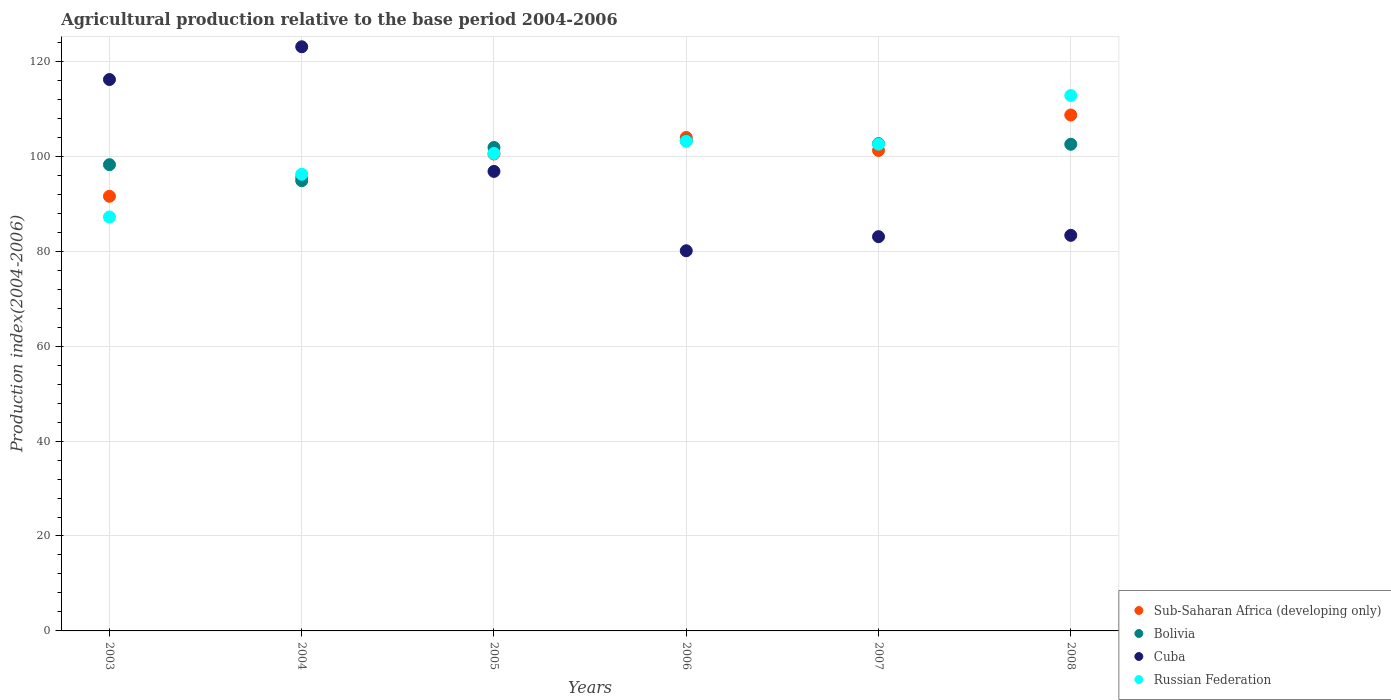How many different coloured dotlines are there?
Offer a terse response. 4. Is the number of dotlines equal to the number of legend labels?
Give a very brief answer. Yes. What is the agricultural production index in Cuba in 2005?
Make the answer very short. 96.82. Across all years, what is the maximum agricultural production index in Sub-Saharan Africa (developing only)?
Offer a terse response. 108.7. Across all years, what is the minimum agricultural production index in Bolivia?
Give a very brief answer. 94.86. In which year was the agricultural production index in Sub-Saharan Africa (developing only) maximum?
Your answer should be very brief. 2008. What is the total agricultural production index in Sub-Saharan Africa (developing only) in the graph?
Offer a very short reply. 601.52. What is the difference between the agricultural production index in Russian Federation in 2003 and that in 2008?
Offer a very short reply. -25.59. What is the difference between the agricultural production index in Bolivia in 2004 and the agricultural production index in Sub-Saharan Africa (developing only) in 2008?
Your response must be concise. -13.84. What is the average agricultural production index in Sub-Saharan Africa (developing only) per year?
Ensure brevity in your answer.  100.25. In the year 2006, what is the difference between the agricultural production index in Sub-Saharan Africa (developing only) and agricultural production index in Bolivia?
Provide a succinct answer. 0.69. In how many years, is the agricultural production index in Russian Federation greater than 80?
Provide a short and direct response. 6. What is the ratio of the agricultural production index in Cuba in 2004 to that in 2007?
Your answer should be very brief. 1.48. Is the difference between the agricultural production index in Sub-Saharan Africa (developing only) in 2003 and 2004 greater than the difference between the agricultural production index in Bolivia in 2003 and 2004?
Your answer should be very brief. No. What is the difference between the highest and the second highest agricultural production index in Cuba?
Keep it short and to the point. 6.9. What is the difference between the highest and the lowest agricultural production index in Cuba?
Your response must be concise. 42.98. Does the agricultural production index in Sub-Saharan Africa (developing only) monotonically increase over the years?
Ensure brevity in your answer.  No. Is the agricultural production index in Sub-Saharan Africa (developing only) strictly greater than the agricultural production index in Cuba over the years?
Give a very brief answer. No. Is the agricultural production index in Bolivia strictly less than the agricultural production index in Russian Federation over the years?
Offer a terse response. No. Does the graph contain any zero values?
Make the answer very short. No. Does the graph contain grids?
Make the answer very short. Yes. How are the legend labels stacked?
Make the answer very short. Vertical. What is the title of the graph?
Your answer should be compact. Agricultural production relative to the base period 2004-2006. Does "Middle East & North Africa (developing only)" appear as one of the legend labels in the graph?
Ensure brevity in your answer.  No. What is the label or title of the X-axis?
Offer a very short reply. Years. What is the label or title of the Y-axis?
Your answer should be compact. Production index(2004-2006). What is the Production index(2004-2006) of Sub-Saharan Africa (developing only) in 2003?
Your answer should be very brief. 91.58. What is the Production index(2004-2006) of Bolivia in 2003?
Make the answer very short. 98.24. What is the Production index(2004-2006) in Cuba in 2003?
Offer a terse response. 116.18. What is the Production index(2004-2006) of Russian Federation in 2003?
Your answer should be compact. 87.22. What is the Production index(2004-2006) of Sub-Saharan Africa (developing only) in 2004?
Provide a succinct answer. 95.55. What is the Production index(2004-2006) of Bolivia in 2004?
Your response must be concise. 94.86. What is the Production index(2004-2006) of Cuba in 2004?
Provide a succinct answer. 123.08. What is the Production index(2004-2006) of Russian Federation in 2004?
Keep it short and to the point. 96.22. What is the Production index(2004-2006) in Sub-Saharan Africa (developing only) in 2005?
Offer a very short reply. 100.48. What is the Production index(2004-2006) in Bolivia in 2005?
Keep it short and to the point. 101.86. What is the Production index(2004-2006) of Cuba in 2005?
Give a very brief answer. 96.82. What is the Production index(2004-2006) in Russian Federation in 2005?
Your answer should be very brief. 100.61. What is the Production index(2004-2006) in Sub-Saharan Africa (developing only) in 2006?
Provide a short and direct response. 103.97. What is the Production index(2004-2006) in Bolivia in 2006?
Give a very brief answer. 103.28. What is the Production index(2004-2006) in Cuba in 2006?
Offer a very short reply. 80.1. What is the Production index(2004-2006) of Russian Federation in 2006?
Provide a short and direct response. 103.17. What is the Production index(2004-2006) of Sub-Saharan Africa (developing only) in 2007?
Your response must be concise. 101.24. What is the Production index(2004-2006) of Bolivia in 2007?
Offer a very short reply. 102.68. What is the Production index(2004-2006) of Cuba in 2007?
Give a very brief answer. 83.07. What is the Production index(2004-2006) in Russian Federation in 2007?
Your answer should be compact. 102.56. What is the Production index(2004-2006) of Sub-Saharan Africa (developing only) in 2008?
Offer a very short reply. 108.7. What is the Production index(2004-2006) of Bolivia in 2008?
Offer a terse response. 102.54. What is the Production index(2004-2006) in Cuba in 2008?
Keep it short and to the point. 83.35. What is the Production index(2004-2006) of Russian Federation in 2008?
Keep it short and to the point. 112.81. Across all years, what is the maximum Production index(2004-2006) of Sub-Saharan Africa (developing only)?
Make the answer very short. 108.7. Across all years, what is the maximum Production index(2004-2006) of Bolivia?
Your answer should be very brief. 103.28. Across all years, what is the maximum Production index(2004-2006) of Cuba?
Your response must be concise. 123.08. Across all years, what is the maximum Production index(2004-2006) of Russian Federation?
Offer a very short reply. 112.81. Across all years, what is the minimum Production index(2004-2006) in Sub-Saharan Africa (developing only)?
Provide a short and direct response. 91.58. Across all years, what is the minimum Production index(2004-2006) of Bolivia?
Your response must be concise. 94.86. Across all years, what is the minimum Production index(2004-2006) in Cuba?
Offer a terse response. 80.1. Across all years, what is the minimum Production index(2004-2006) in Russian Federation?
Your answer should be very brief. 87.22. What is the total Production index(2004-2006) of Sub-Saharan Africa (developing only) in the graph?
Your answer should be very brief. 601.52. What is the total Production index(2004-2006) in Bolivia in the graph?
Make the answer very short. 603.46. What is the total Production index(2004-2006) in Cuba in the graph?
Your response must be concise. 582.6. What is the total Production index(2004-2006) in Russian Federation in the graph?
Provide a succinct answer. 602.59. What is the difference between the Production index(2004-2006) in Sub-Saharan Africa (developing only) in 2003 and that in 2004?
Offer a terse response. -3.97. What is the difference between the Production index(2004-2006) in Bolivia in 2003 and that in 2004?
Offer a terse response. 3.38. What is the difference between the Production index(2004-2006) of Cuba in 2003 and that in 2004?
Offer a terse response. -6.9. What is the difference between the Production index(2004-2006) of Sub-Saharan Africa (developing only) in 2003 and that in 2005?
Your answer should be very brief. -8.9. What is the difference between the Production index(2004-2006) in Bolivia in 2003 and that in 2005?
Give a very brief answer. -3.62. What is the difference between the Production index(2004-2006) of Cuba in 2003 and that in 2005?
Your answer should be compact. 19.36. What is the difference between the Production index(2004-2006) in Russian Federation in 2003 and that in 2005?
Provide a succinct answer. -13.39. What is the difference between the Production index(2004-2006) of Sub-Saharan Africa (developing only) in 2003 and that in 2006?
Offer a very short reply. -12.4. What is the difference between the Production index(2004-2006) in Bolivia in 2003 and that in 2006?
Offer a very short reply. -5.04. What is the difference between the Production index(2004-2006) in Cuba in 2003 and that in 2006?
Your answer should be compact. 36.08. What is the difference between the Production index(2004-2006) of Russian Federation in 2003 and that in 2006?
Make the answer very short. -15.95. What is the difference between the Production index(2004-2006) of Sub-Saharan Africa (developing only) in 2003 and that in 2007?
Give a very brief answer. -9.67. What is the difference between the Production index(2004-2006) of Bolivia in 2003 and that in 2007?
Ensure brevity in your answer.  -4.44. What is the difference between the Production index(2004-2006) of Cuba in 2003 and that in 2007?
Ensure brevity in your answer.  33.11. What is the difference between the Production index(2004-2006) of Russian Federation in 2003 and that in 2007?
Give a very brief answer. -15.34. What is the difference between the Production index(2004-2006) of Sub-Saharan Africa (developing only) in 2003 and that in 2008?
Offer a very short reply. -17.13. What is the difference between the Production index(2004-2006) of Cuba in 2003 and that in 2008?
Provide a succinct answer. 32.83. What is the difference between the Production index(2004-2006) in Russian Federation in 2003 and that in 2008?
Your answer should be compact. -25.59. What is the difference between the Production index(2004-2006) in Sub-Saharan Africa (developing only) in 2004 and that in 2005?
Make the answer very short. -4.93. What is the difference between the Production index(2004-2006) of Cuba in 2004 and that in 2005?
Give a very brief answer. 26.26. What is the difference between the Production index(2004-2006) in Russian Federation in 2004 and that in 2005?
Your response must be concise. -4.39. What is the difference between the Production index(2004-2006) in Sub-Saharan Africa (developing only) in 2004 and that in 2006?
Make the answer very short. -8.43. What is the difference between the Production index(2004-2006) of Bolivia in 2004 and that in 2006?
Ensure brevity in your answer.  -8.42. What is the difference between the Production index(2004-2006) of Cuba in 2004 and that in 2006?
Provide a short and direct response. 42.98. What is the difference between the Production index(2004-2006) of Russian Federation in 2004 and that in 2006?
Ensure brevity in your answer.  -6.95. What is the difference between the Production index(2004-2006) in Sub-Saharan Africa (developing only) in 2004 and that in 2007?
Ensure brevity in your answer.  -5.69. What is the difference between the Production index(2004-2006) in Bolivia in 2004 and that in 2007?
Make the answer very short. -7.82. What is the difference between the Production index(2004-2006) of Cuba in 2004 and that in 2007?
Make the answer very short. 40.01. What is the difference between the Production index(2004-2006) in Russian Federation in 2004 and that in 2007?
Your response must be concise. -6.34. What is the difference between the Production index(2004-2006) of Sub-Saharan Africa (developing only) in 2004 and that in 2008?
Give a very brief answer. -13.15. What is the difference between the Production index(2004-2006) in Bolivia in 2004 and that in 2008?
Provide a short and direct response. -7.68. What is the difference between the Production index(2004-2006) of Cuba in 2004 and that in 2008?
Your answer should be very brief. 39.73. What is the difference between the Production index(2004-2006) in Russian Federation in 2004 and that in 2008?
Provide a short and direct response. -16.59. What is the difference between the Production index(2004-2006) of Sub-Saharan Africa (developing only) in 2005 and that in 2006?
Offer a terse response. -3.5. What is the difference between the Production index(2004-2006) in Bolivia in 2005 and that in 2006?
Offer a terse response. -1.42. What is the difference between the Production index(2004-2006) in Cuba in 2005 and that in 2006?
Your answer should be very brief. 16.72. What is the difference between the Production index(2004-2006) in Russian Federation in 2005 and that in 2006?
Offer a very short reply. -2.56. What is the difference between the Production index(2004-2006) of Sub-Saharan Africa (developing only) in 2005 and that in 2007?
Your answer should be compact. -0.76. What is the difference between the Production index(2004-2006) in Bolivia in 2005 and that in 2007?
Offer a very short reply. -0.82. What is the difference between the Production index(2004-2006) in Cuba in 2005 and that in 2007?
Give a very brief answer. 13.75. What is the difference between the Production index(2004-2006) of Russian Federation in 2005 and that in 2007?
Give a very brief answer. -1.95. What is the difference between the Production index(2004-2006) in Sub-Saharan Africa (developing only) in 2005 and that in 2008?
Keep it short and to the point. -8.22. What is the difference between the Production index(2004-2006) in Bolivia in 2005 and that in 2008?
Ensure brevity in your answer.  -0.68. What is the difference between the Production index(2004-2006) in Cuba in 2005 and that in 2008?
Ensure brevity in your answer.  13.47. What is the difference between the Production index(2004-2006) of Russian Federation in 2005 and that in 2008?
Provide a short and direct response. -12.2. What is the difference between the Production index(2004-2006) of Sub-Saharan Africa (developing only) in 2006 and that in 2007?
Keep it short and to the point. 2.73. What is the difference between the Production index(2004-2006) in Bolivia in 2006 and that in 2007?
Keep it short and to the point. 0.6. What is the difference between the Production index(2004-2006) in Cuba in 2006 and that in 2007?
Offer a very short reply. -2.97. What is the difference between the Production index(2004-2006) in Russian Federation in 2006 and that in 2007?
Provide a succinct answer. 0.61. What is the difference between the Production index(2004-2006) of Sub-Saharan Africa (developing only) in 2006 and that in 2008?
Make the answer very short. -4.73. What is the difference between the Production index(2004-2006) of Bolivia in 2006 and that in 2008?
Provide a succinct answer. 0.74. What is the difference between the Production index(2004-2006) of Cuba in 2006 and that in 2008?
Offer a terse response. -3.25. What is the difference between the Production index(2004-2006) of Russian Federation in 2006 and that in 2008?
Your answer should be compact. -9.64. What is the difference between the Production index(2004-2006) in Sub-Saharan Africa (developing only) in 2007 and that in 2008?
Provide a short and direct response. -7.46. What is the difference between the Production index(2004-2006) of Bolivia in 2007 and that in 2008?
Provide a short and direct response. 0.14. What is the difference between the Production index(2004-2006) in Cuba in 2007 and that in 2008?
Offer a very short reply. -0.28. What is the difference between the Production index(2004-2006) of Russian Federation in 2007 and that in 2008?
Ensure brevity in your answer.  -10.25. What is the difference between the Production index(2004-2006) of Sub-Saharan Africa (developing only) in 2003 and the Production index(2004-2006) of Bolivia in 2004?
Offer a very short reply. -3.28. What is the difference between the Production index(2004-2006) in Sub-Saharan Africa (developing only) in 2003 and the Production index(2004-2006) in Cuba in 2004?
Give a very brief answer. -31.5. What is the difference between the Production index(2004-2006) of Sub-Saharan Africa (developing only) in 2003 and the Production index(2004-2006) of Russian Federation in 2004?
Keep it short and to the point. -4.64. What is the difference between the Production index(2004-2006) in Bolivia in 2003 and the Production index(2004-2006) in Cuba in 2004?
Provide a succinct answer. -24.84. What is the difference between the Production index(2004-2006) of Bolivia in 2003 and the Production index(2004-2006) of Russian Federation in 2004?
Make the answer very short. 2.02. What is the difference between the Production index(2004-2006) in Cuba in 2003 and the Production index(2004-2006) in Russian Federation in 2004?
Your response must be concise. 19.96. What is the difference between the Production index(2004-2006) of Sub-Saharan Africa (developing only) in 2003 and the Production index(2004-2006) of Bolivia in 2005?
Offer a terse response. -10.28. What is the difference between the Production index(2004-2006) of Sub-Saharan Africa (developing only) in 2003 and the Production index(2004-2006) of Cuba in 2005?
Your answer should be very brief. -5.24. What is the difference between the Production index(2004-2006) in Sub-Saharan Africa (developing only) in 2003 and the Production index(2004-2006) in Russian Federation in 2005?
Offer a terse response. -9.03. What is the difference between the Production index(2004-2006) in Bolivia in 2003 and the Production index(2004-2006) in Cuba in 2005?
Give a very brief answer. 1.42. What is the difference between the Production index(2004-2006) in Bolivia in 2003 and the Production index(2004-2006) in Russian Federation in 2005?
Your response must be concise. -2.37. What is the difference between the Production index(2004-2006) in Cuba in 2003 and the Production index(2004-2006) in Russian Federation in 2005?
Ensure brevity in your answer.  15.57. What is the difference between the Production index(2004-2006) in Sub-Saharan Africa (developing only) in 2003 and the Production index(2004-2006) in Bolivia in 2006?
Provide a short and direct response. -11.7. What is the difference between the Production index(2004-2006) of Sub-Saharan Africa (developing only) in 2003 and the Production index(2004-2006) of Cuba in 2006?
Your answer should be very brief. 11.48. What is the difference between the Production index(2004-2006) of Sub-Saharan Africa (developing only) in 2003 and the Production index(2004-2006) of Russian Federation in 2006?
Provide a succinct answer. -11.59. What is the difference between the Production index(2004-2006) in Bolivia in 2003 and the Production index(2004-2006) in Cuba in 2006?
Ensure brevity in your answer.  18.14. What is the difference between the Production index(2004-2006) in Bolivia in 2003 and the Production index(2004-2006) in Russian Federation in 2006?
Offer a terse response. -4.93. What is the difference between the Production index(2004-2006) of Cuba in 2003 and the Production index(2004-2006) of Russian Federation in 2006?
Offer a very short reply. 13.01. What is the difference between the Production index(2004-2006) in Sub-Saharan Africa (developing only) in 2003 and the Production index(2004-2006) in Bolivia in 2007?
Keep it short and to the point. -11.1. What is the difference between the Production index(2004-2006) in Sub-Saharan Africa (developing only) in 2003 and the Production index(2004-2006) in Cuba in 2007?
Give a very brief answer. 8.51. What is the difference between the Production index(2004-2006) of Sub-Saharan Africa (developing only) in 2003 and the Production index(2004-2006) of Russian Federation in 2007?
Offer a terse response. -10.98. What is the difference between the Production index(2004-2006) of Bolivia in 2003 and the Production index(2004-2006) of Cuba in 2007?
Your answer should be compact. 15.17. What is the difference between the Production index(2004-2006) in Bolivia in 2003 and the Production index(2004-2006) in Russian Federation in 2007?
Your answer should be very brief. -4.32. What is the difference between the Production index(2004-2006) of Cuba in 2003 and the Production index(2004-2006) of Russian Federation in 2007?
Your answer should be very brief. 13.62. What is the difference between the Production index(2004-2006) in Sub-Saharan Africa (developing only) in 2003 and the Production index(2004-2006) in Bolivia in 2008?
Ensure brevity in your answer.  -10.96. What is the difference between the Production index(2004-2006) in Sub-Saharan Africa (developing only) in 2003 and the Production index(2004-2006) in Cuba in 2008?
Your answer should be very brief. 8.23. What is the difference between the Production index(2004-2006) of Sub-Saharan Africa (developing only) in 2003 and the Production index(2004-2006) of Russian Federation in 2008?
Your response must be concise. -21.23. What is the difference between the Production index(2004-2006) of Bolivia in 2003 and the Production index(2004-2006) of Cuba in 2008?
Give a very brief answer. 14.89. What is the difference between the Production index(2004-2006) in Bolivia in 2003 and the Production index(2004-2006) in Russian Federation in 2008?
Keep it short and to the point. -14.57. What is the difference between the Production index(2004-2006) in Cuba in 2003 and the Production index(2004-2006) in Russian Federation in 2008?
Give a very brief answer. 3.37. What is the difference between the Production index(2004-2006) in Sub-Saharan Africa (developing only) in 2004 and the Production index(2004-2006) in Bolivia in 2005?
Provide a short and direct response. -6.31. What is the difference between the Production index(2004-2006) of Sub-Saharan Africa (developing only) in 2004 and the Production index(2004-2006) of Cuba in 2005?
Ensure brevity in your answer.  -1.27. What is the difference between the Production index(2004-2006) in Sub-Saharan Africa (developing only) in 2004 and the Production index(2004-2006) in Russian Federation in 2005?
Provide a short and direct response. -5.06. What is the difference between the Production index(2004-2006) of Bolivia in 2004 and the Production index(2004-2006) of Cuba in 2005?
Keep it short and to the point. -1.96. What is the difference between the Production index(2004-2006) of Bolivia in 2004 and the Production index(2004-2006) of Russian Federation in 2005?
Give a very brief answer. -5.75. What is the difference between the Production index(2004-2006) of Cuba in 2004 and the Production index(2004-2006) of Russian Federation in 2005?
Give a very brief answer. 22.47. What is the difference between the Production index(2004-2006) in Sub-Saharan Africa (developing only) in 2004 and the Production index(2004-2006) in Bolivia in 2006?
Keep it short and to the point. -7.73. What is the difference between the Production index(2004-2006) in Sub-Saharan Africa (developing only) in 2004 and the Production index(2004-2006) in Cuba in 2006?
Keep it short and to the point. 15.45. What is the difference between the Production index(2004-2006) of Sub-Saharan Africa (developing only) in 2004 and the Production index(2004-2006) of Russian Federation in 2006?
Your answer should be compact. -7.62. What is the difference between the Production index(2004-2006) in Bolivia in 2004 and the Production index(2004-2006) in Cuba in 2006?
Provide a short and direct response. 14.76. What is the difference between the Production index(2004-2006) of Bolivia in 2004 and the Production index(2004-2006) of Russian Federation in 2006?
Keep it short and to the point. -8.31. What is the difference between the Production index(2004-2006) of Cuba in 2004 and the Production index(2004-2006) of Russian Federation in 2006?
Your answer should be compact. 19.91. What is the difference between the Production index(2004-2006) in Sub-Saharan Africa (developing only) in 2004 and the Production index(2004-2006) in Bolivia in 2007?
Offer a terse response. -7.13. What is the difference between the Production index(2004-2006) of Sub-Saharan Africa (developing only) in 2004 and the Production index(2004-2006) of Cuba in 2007?
Offer a very short reply. 12.48. What is the difference between the Production index(2004-2006) in Sub-Saharan Africa (developing only) in 2004 and the Production index(2004-2006) in Russian Federation in 2007?
Provide a succinct answer. -7.01. What is the difference between the Production index(2004-2006) of Bolivia in 2004 and the Production index(2004-2006) of Cuba in 2007?
Offer a terse response. 11.79. What is the difference between the Production index(2004-2006) in Bolivia in 2004 and the Production index(2004-2006) in Russian Federation in 2007?
Your answer should be very brief. -7.7. What is the difference between the Production index(2004-2006) of Cuba in 2004 and the Production index(2004-2006) of Russian Federation in 2007?
Your response must be concise. 20.52. What is the difference between the Production index(2004-2006) in Sub-Saharan Africa (developing only) in 2004 and the Production index(2004-2006) in Bolivia in 2008?
Give a very brief answer. -6.99. What is the difference between the Production index(2004-2006) of Sub-Saharan Africa (developing only) in 2004 and the Production index(2004-2006) of Cuba in 2008?
Ensure brevity in your answer.  12.2. What is the difference between the Production index(2004-2006) in Sub-Saharan Africa (developing only) in 2004 and the Production index(2004-2006) in Russian Federation in 2008?
Make the answer very short. -17.26. What is the difference between the Production index(2004-2006) in Bolivia in 2004 and the Production index(2004-2006) in Cuba in 2008?
Ensure brevity in your answer.  11.51. What is the difference between the Production index(2004-2006) of Bolivia in 2004 and the Production index(2004-2006) of Russian Federation in 2008?
Provide a succinct answer. -17.95. What is the difference between the Production index(2004-2006) of Cuba in 2004 and the Production index(2004-2006) of Russian Federation in 2008?
Make the answer very short. 10.27. What is the difference between the Production index(2004-2006) in Sub-Saharan Africa (developing only) in 2005 and the Production index(2004-2006) in Bolivia in 2006?
Your answer should be very brief. -2.8. What is the difference between the Production index(2004-2006) of Sub-Saharan Africa (developing only) in 2005 and the Production index(2004-2006) of Cuba in 2006?
Make the answer very short. 20.38. What is the difference between the Production index(2004-2006) in Sub-Saharan Africa (developing only) in 2005 and the Production index(2004-2006) in Russian Federation in 2006?
Provide a short and direct response. -2.69. What is the difference between the Production index(2004-2006) of Bolivia in 2005 and the Production index(2004-2006) of Cuba in 2006?
Your response must be concise. 21.76. What is the difference between the Production index(2004-2006) in Bolivia in 2005 and the Production index(2004-2006) in Russian Federation in 2006?
Ensure brevity in your answer.  -1.31. What is the difference between the Production index(2004-2006) in Cuba in 2005 and the Production index(2004-2006) in Russian Federation in 2006?
Ensure brevity in your answer.  -6.35. What is the difference between the Production index(2004-2006) of Sub-Saharan Africa (developing only) in 2005 and the Production index(2004-2006) of Bolivia in 2007?
Your answer should be compact. -2.2. What is the difference between the Production index(2004-2006) in Sub-Saharan Africa (developing only) in 2005 and the Production index(2004-2006) in Cuba in 2007?
Keep it short and to the point. 17.41. What is the difference between the Production index(2004-2006) in Sub-Saharan Africa (developing only) in 2005 and the Production index(2004-2006) in Russian Federation in 2007?
Your answer should be compact. -2.08. What is the difference between the Production index(2004-2006) in Bolivia in 2005 and the Production index(2004-2006) in Cuba in 2007?
Give a very brief answer. 18.79. What is the difference between the Production index(2004-2006) of Cuba in 2005 and the Production index(2004-2006) of Russian Federation in 2007?
Offer a very short reply. -5.74. What is the difference between the Production index(2004-2006) in Sub-Saharan Africa (developing only) in 2005 and the Production index(2004-2006) in Bolivia in 2008?
Your answer should be compact. -2.06. What is the difference between the Production index(2004-2006) in Sub-Saharan Africa (developing only) in 2005 and the Production index(2004-2006) in Cuba in 2008?
Give a very brief answer. 17.13. What is the difference between the Production index(2004-2006) in Sub-Saharan Africa (developing only) in 2005 and the Production index(2004-2006) in Russian Federation in 2008?
Ensure brevity in your answer.  -12.33. What is the difference between the Production index(2004-2006) of Bolivia in 2005 and the Production index(2004-2006) of Cuba in 2008?
Make the answer very short. 18.51. What is the difference between the Production index(2004-2006) of Bolivia in 2005 and the Production index(2004-2006) of Russian Federation in 2008?
Your answer should be compact. -10.95. What is the difference between the Production index(2004-2006) in Cuba in 2005 and the Production index(2004-2006) in Russian Federation in 2008?
Offer a terse response. -15.99. What is the difference between the Production index(2004-2006) of Sub-Saharan Africa (developing only) in 2006 and the Production index(2004-2006) of Bolivia in 2007?
Offer a terse response. 1.29. What is the difference between the Production index(2004-2006) of Sub-Saharan Africa (developing only) in 2006 and the Production index(2004-2006) of Cuba in 2007?
Give a very brief answer. 20.9. What is the difference between the Production index(2004-2006) of Sub-Saharan Africa (developing only) in 2006 and the Production index(2004-2006) of Russian Federation in 2007?
Offer a terse response. 1.41. What is the difference between the Production index(2004-2006) in Bolivia in 2006 and the Production index(2004-2006) in Cuba in 2007?
Offer a terse response. 20.21. What is the difference between the Production index(2004-2006) of Bolivia in 2006 and the Production index(2004-2006) of Russian Federation in 2007?
Your answer should be compact. 0.72. What is the difference between the Production index(2004-2006) of Cuba in 2006 and the Production index(2004-2006) of Russian Federation in 2007?
Provide a short and direct response. -22.46. What is the difference between the Production index(2004-2006) in Sub-Saharan Africa (developing only) in 2006 and the Production index(2004-2006) in Bolivia in 2008?
Your answer should be very brief. 1.43. What is the difference between the Production index(2004-2006) in Sub-Saharan Africa (developing only) in 2006 and the Production index(2004-2006) in Cuba in 2008?
Make the answer very short. 20.62. What is the difference between the Production index(2004-2006) in Sub-Saharan Africa (developing only) in 2006 and the Production index(2004-2006) in Russian Federation in 2008?
Offer a terse response. -8.84. What is the difference between the Production index(2004-2006) of Bolivia in 2006 and the Production index(2004-2006) of Cuba in 2008?
Offer a terse response. 19.93. What is the difference between the Production index(2004-2006) of Bolivia in 2006 and the Production index(2004-2006) of Russian Federation in 2008?
Provide a succinct answer. -9.53. What is the difference between the Production index(2004-2006) of Cuba in 2006 and the Production index(2004-2006) of Russian Federation in 2008?
Provide a short and direct response. -32.71. What is the difference between the Production index(2004-2006) of Sub-Saharan Africa (developing only) in 2007 and the Production index(2004-2006) of Bolivia in 2008?
Your answer should be very brief. -1.3. What is the difference between the Production index(2004-2006) in Sub-Saharan Africa (developing only) in 2007 and the Production index(2004-2006) in Cuba in 2008?
Ensure brevity in your answer.  17.89. What is the difference between the Production index(2004-2006) in Sub-Saharan Africa (developing only) in 2007 and the Production index(2004-2006) in Russian Federation in 2008?
Your response must be concise. -11.57. What is the difference between the Production index(2004-2006) of Bolivia in 2007 and the Production index(2004-2006) of Cuba in 2008?
Give a very brief answer. 19.33. What is the difference between the Production index(2004-2006) in Bolivia in 2007 and the Production index(2004-2006) in Russian Federation in 2008?
Give a very brief answer. -10.13. What is the difference between the Production index(2004-2006) in Cuba in 2007 and the Production index(2004-2006) in Russian Federation in 2008?
Provide a succinct answer. -29.74. What is the average Production index(2004-2006) in Sub-Saharan Africa (developing only) per year?
Your answer should be very brief. 100.25. What is the average Production index(2004-2006) in Bolivia per year?
Your answer should be very brief. 100.58. What is the average Production index(2004-2006) in Cuba per year?
Keep it short and to the point. 97.1. What is the average Production index(2004-2006) in Russian Federation per year?
Offer a very short reply. 100.43. In the year 2003, what is the difference between the Production index(2004-2006) of Sub-Saharan Africa (developing only) and Production index(2004-2006) of Bolivia?
Your response must be concise. -6.66. In the year 2003, what is the difference between the Production index(2004-2006) in Sub-Saharan Africa (developing only) and Production index(2004-2006) in Cuba?
Offer a very short reply. -24.6. In the year 2003, what is the difference between the Production index(2004-2006) in Sub-Saharan Africa (developing only) and Production index(2004-2006) in Russian Federation?
Your response must be concise. 4.36. In the year 2003, what is the difference between the Production index(2004-2006) of Bolivia and Production index(2004-2006) of Cuba?
Give a very brief answer. -17.94. In the year 2003, what is the difference between the Production index(2004-2006) in Bolivia and Production index(2004-2006) in Russian Federation?
Your response must be concise. 11.02. In the year 2003, what is the difference between the Production index(2004-2006) of Cuba and Production index(2004-2006) of Russian Federation?
Make the answer very short. 28.96. In the year 2004, what is the difference between the Production index(2004-2006) in Sub-Saharan Africa (developing only) and Production index(2004-2006) in Bolivia?
Your answer should be very brief. 0.69. In the year 2004, what is the difference between the Production index(2004-2006) of Sub-Saharan Africa (developing only) and Production index(2004-2006) of Cuba?
Your answer should be very brief. -27.53. In the year 2004, what is the difference between the Production index(2004-2006) in Sub-Saharan Africa (developing only) and Production index(2004-2006) in Russian Federation?
Your answer should be compact. -0.67. In the year 2004, what is the difference between the Production index(2004-2006) in Bolivia and Production index(2004-2006) in Cuba?
Provide a short and direct response. -28.22. In the year 2004, what is the difference between the Production index(2004-2006) of Bolivia and Production index(2004-2006) of Russian Federation?
Make the answer very short. -1.36. In the year 2004, what is the difference between the Production index(2004-2006) in Cuba and Production index(2004-2006) in Russian Federation?
Provide a succinct answer. 26.86. In the year 2005, what is the difference between the Production index(2004-2006) in Sub-Saharan Africa (developing only) and Production index(2004-2006) in Bolivia?
Keep it short and to the point. -1.38. In the year 2005, what is the difference between the Production index(2004-2006) in Sub-Saharan Africa (developing only) and Production index(2004-2006) in Cuba?
Give a very brief answer. 3.66. In the year 2005, what is the difference between the Production index(2004-2006) in Sub-Saharan Africa (developing only) and Production index(2004-2006) in Russian Federation?
Provide a short and direct response. -0.13. In the year 2005, what is the difference between the Production index(2004-2006) in Bolivia and Production index(2004-2006) in Cuba?
Make the answer very short. 5.04. In the year 2005, what is the difference between the Production index(2004-2006) in Cuba and Production index(2004-2006) in Russian Federation?
Offer a very short reply. -3.79. In the year 2006, what is the difference between the Production index(2004-2006) in Sub-Saharan Africa (developing only) and Production index(2004-2006) in Bolivia?
Keep it short and to the point. 0.69. In the year 2006, what is the difference between the Production index(2004-2006) in Sub-Saharan Africa (developing only) and Production index(2004-2006) in Cuba?
Your answer should be very brief. 23.87. In the year 2006, what is the difference between the Production index(2004-2006) of Sub-Saharan Africa (developing only) and Production index(2004-2006) of Russian Federation?
Offer a very short reply. 0.8. In the year 2006, what is the difference between the Production index(2004-2006) of Bolivia and Production index(2004-2006) of Cuba?
Give a very brief answer. 23.18. In the year 2006, what is the difference between the Production index(2004-2006) of Bolivia and Production index(2004-2006) of Russian Federation?
Your answer should be compact. 0.11. In the year 2006, what is the difference between the Production index(2004-2006) in Cuba and Production index(2004-2006) in Russian Federation?
Your response must be concise. -23.07. In the year 2007, what is the difference between the Production index(2004-2006) of Sub-Saharan Africa (developing only) and Production index(2004-2006) of Bolivia?
Your answer should be very brief. -1.44. In the year 2007, what is the difference between the Production index(2004-2006) of Sub-Saharan Africa (developing only) and Production index(2004-2006) of Cuba?
Your response must be concise. 18.17. In the year 2007, what is the difference between the Production index(2004-2006) of Sub-Saharan Africa (developing only) and Production index(2004-2006) of Russian Federation?
Provide a succinct answer. -1.32. In the year 2007, what is the difference between the Production index(2004-2006) of Bolivia and Production index(2004-2006) of Cuba?
Provide a succinct answer. 19.61. In the year 2007, what is the difference between the Production index(2004-2006) of Bolivia and Production index(2004-2006) of Russian Federation?
Ensure brevity in your answer.  0.12. In the year 2007, what is the difference between the Production index(2004-2006) of Cuba and Production index(2004-2006) of Russian Federation?
Your answer should be very brief. -19.49. In the year 2008, what is the difference between the Production index(2004-2006) of Sub-Saharan Africa (developing only) and Production index(2004-2006) of Bolivia?
Offer a very short reply. 6.16. In the year 2008, what is the difference between the Production index(2004-2006) in Sub-Saharan Africa (developing only) and Production index(2004-2006) in Cuba?
Your answer should be compact. 25.35. In the year 2008, what is the difference between the Production index(2004-2006) of Sub-Saharan Africa (developing only) and Production index(2004-2006) of Russian Federation?
Keep it short and to the point. -4.11. In the year 2008, what is the difference between the Production index(2004-2006) in Bolivia and Production index(2004-2006) in Cuba?
Keep it short and to the point. 19.19. In the year 2008, what is the difference between the Production index(2004-2006) of Bolivia and Production index(2004-2006) of Russian Federation?
Offer a terse response. -10.27. In the year 2008, what is the difference between the Production index(2004-2006) of Cuba and Production index(2004-2006) of Russian Federation?
Provide a succinct answer. -29.46. What is the ratio of the Production index(2004-2006) of Sub-Saharan Africa (developing only) in 2003 to that in 2004?
Make the answer very short. 0.96. What is the ratio of the Production index(2004-2006) of Bolivia in 2003 to that in 2004?
Offer a terse response. 1.04. What is the ratio of the Production index(2004-2006) in Cuba in 2003 to that in 2004?
Your answer should be very brief. 0.94. What is the ratio of the Production index(2004-2006) in Russian Federation in 2003 to that in 2004?
Provide a succinct answer. 0.91. What is the ratio of the Production index(2004-2006) of Sub-Saharan Africa (developing only) in 2003 to that in 2005?
Give a very brief answer. 0.91. What is the ratio of the Production index(2004-2006) of Bolivia in 2003 to that in 2005?
Offer a very short reply. 0.96. What is the ratio of the Production index(2004-2006) in Cuba in 2003 to that in 2005?
Provide a short and direct response. 1.2. What is the ratio of the Production index(2004-2006) in Russian Federation in 2003 to that in 2005?
Ensure brevity in your answer.  0.87. What is the ratio of the Production index(2004-2006) in Sub-Saharan Africa (developing only) in 2003 to that in 2006?
Your answer should be compact. 0.88. What is the ratio of the Production index(2004-2006) in Bolivia in 2003 to that in 2006?
Offer a very short reply. 0.95. What is the ratio of the Production index(2004-2006) in Cuba in 2003 to that in 2006?
Your answer should be compact. 1.45. What is the ratio of the Production index(2004-2006) of Russian Federation in 2003 to that in 2006?
Offer a terse response. 0.85. What is the ratio of the Production index(2004-2006) in Sub-Saharan Africa (developing only) in 2003 to that in 2007?
Provide a short and direct response. 0.9. What is the ratio of the Production index(2004-2006) in Bolivia in 2003 to that in 2007?
Ensure brevity in your answer.  0.96. What is the ratio of the Production index(2004-2006) of Cuba in 2003 to that in 2007?
Your response must be concise. 1.4. What is the ratio of the Production index(2004-2006) in Russian Federation in 2003 to that in 2007?
Provide a succinct answer. 0.85. What is the ratio of the Production index(2004-2006) of Sub-Saharan Africa (developing only) in 2003 to that in 2008?
Your answer should be compact. 0.84. What is the ratio of the Production index(2004-2006) in Bolivia in 2003 to that in 2008?
Your answer should be very brief. 0.96. What is the ratio of the Production index(2004-2006) of Cuba in 2003 to that in 2008?
Give a very brief answer. 1.39. What is the ratio of the Production index(2004-2006) of Russian Federation in 2003 to that in 2008?
Make the answer very short. 0.77. What is the ratio of the Production index(2004-2006) of Sub-Saharan Africa (developing only) in 2004 to that in 2005?
Provide a succinct answer. 0.95. What is the ratio of the Production index(2004-2006) of Bolivia in 2004 to that in 2005?
Ensure brevity in your answer.  0.93. What is the ratio of the Production index(2004-2006) in Cuba in 2004 to that in 2005?
Provide a succinct answer. 1.27. What is the ratio of the Production index(2004-2006) in Russian Federation in 2004 to that in 2005?
Provide a succinct answer. 0.96. What is the ratio of the Production index(2004-2006) in Sub-Saharan Africa (developing only) in 2004 to that in 2006?
Make the answer very short. 0.92. What is the ratio of the Production index(2004-2006) in Bolivia in 2004 to that in 2006?
Offer a terse response. 0.92. What is the ratio of the Production index(2004-2006) in Cuba in 2004 to that in 2006?
Provide a short and direct response. 1.54. What is the ratio of the Production index(2004-2006) in Russian Federation in 2004 to that in 2006?
Give a very brief answer. 0.93. What is the ratio of the Production index(2004-2006) in Sub-Saharan Africa (developing only) in 2004 to that in 2007?
Ensure brevity in your answer.  0.94. What is the ratio of the Production index(2004-2006) in Bolivia in 2004 to that in 2007?
Keep it short and to the point. 0.92. What is the ratio of the Production index(2004-2006) in Cuba in 2004 to that in 2007?
Give a very brief answer. 1.48. What is the ratio of the Production index(2004-2006) in Russian Federation in 2004 to that in 2007?
Make the answer very short. 0.94. What is the ratio of the Production index(2004-2006) of Sub-Saharan Africa (developing only) in 2004 to that in 2008?
Your answer should be compact. 0.88. What is the ratio of the Production index(2004-2006) in Bolivia in 2004 to that in 2008?
Keep it short and to the point. 0.93. What is the ratio of the Production index(2004-2006) of Cuba in 2004 to that in 2008?
Keep it short and to the point. 1.48. What is the ratio of the Production index(2004-2006) of Russian Federation in 2004 to that in 2008?
Make the answer very short. 0.85. What is the ratio of the Production index(2004-2006) of Sub-Saharan Africa (developing only) in 2005 to that in 2006?
Give a very brief answer. 0.97. What is the ratio of the Production index(2004-2006) in Bolivia in 2005 to that in 2006?
Ensure brevity in your answer.  0.99. What is the ratio of the Production index(2004-2006) of Cuba in 2005 to that in 2006?
Provide a succinct answer. 1.21. What is the ratio of the Production index(2004-2006) of Russian Federation in 2005 to that in 2006?
Offer a terse response. 0.98. What is the ratio of the Production index(2004-2006) in Sub-Saharan Africa (developing only) in 2005 to that in 2007?
Make the answer very short. 0.99. What is the ratio of the Production index(2004-2006) in Cuba in 2005 to that in 2007?
Provide a short and direct response. 1.17. What is the ratio of the Production index(2004-2006) in Sub-Saharan Africa (developing only) in 2005 to that in 2008?
Make the answer very short. 0.92. What is the ratio of the Production index(2004-2006) in Cuba in 2005 to that in 2008?
Provide a short and direct response. 1.16. What is the ratio of the Production index(2004-2006) in Russian Federation in 2005 to that in 2008?
Give a very brief answer. 0.89. What is the ratio of the Production index(2004-2006) of Cuba in 2006 to that in 2007?
Your answer should be compact. 0.96. What is the ratio of the Production index(2004-2006) of Russian Federation in 2006 to that in 2007?
Offer a very short reply. 1.01. What is the ratio of the Production index(2004-2006) of Sub-Saharan Africa (developing only) in 2006 to that in 2008?
Provide a short and direct response. 0.96. What is the ratio of the Production index(2004-2006) in Russian Federation in 2006 to that in 2008?
Offer a terse response. 0.91. What is the ratio of the Production index(2004-2006) of Sub-Saharan Africa (developing only) in 2007 to that in 2008?
Keep it short and to the point. 0.93. What is the ratio of the Production index(2004-2006) of Bolivia in 2007 to that in 2008?
Your answer should be very brief. 1. What is the difference between the highest and the second highest Production index(2004-2006) of Sub-Saharan Africa (developing only)?
Make the answer very short. 4.73. What is the difference between the highest and the second highest Production index(2004-2006) of Cuba?
Your answer should be compact. 6.9. What is the difference between the highest and the second highest Production index(2004-2006) of Russian Federation?
Offer a terse response. 9.64. What is the difference between the highest and the lowest Production index(2004-2006) in Sub-Saharan Africa (developing only)?
Make the answer very short. 17.13. What is the difference between the highest and the lowest Production index(2004-2006) of Bolivia?
Offer a terse response. 8.42. What is the difference between the highest and the lowest Production index(2004-2006) of Cuba?
Provide a short and direct response. 42.98. What is the difference between the highest and the lowest Production index(2004-2006) of Russian Federation?
Keep it short and to the point. 25.59. 